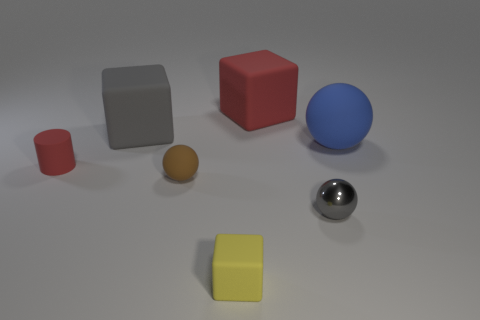Is the color of the tiny metallic thing the same as the tiny matte ball?
Your answer should be very brief. No. There is a red matte object that is the same size as the gray sphere; what is its shape?
Offer a terse response. Cylinder. The brown sphere has what size?
Keep it short and to the point. Small. There is a matte sphere that is right of the small brown object; does it have the same size as the rubber block that is in front of the gray ball?
Offer a terse response. No. There is a rubber cube in front of the red matte thing that is to the left of the large red cube; what is its color?
Provide a short and direct response. Yellow. What material is the gray thing that is the same size as the matte cylinder?
Make the answer very short. Metal. What number of matte objects are either tiny gray spheres or large red cubes?
Keep it short and to the point. 1. The sphere that is both to the right of the big red object and in front of the blue matte thing is what color?
Keep it short and to the point. Gray. What number of big red matte cubes are behind the small yellow rubber block?
Ensure brevity in your answer.  1. What is the tiny gray sphere made of?
Keep it short and to the point. Metal. 